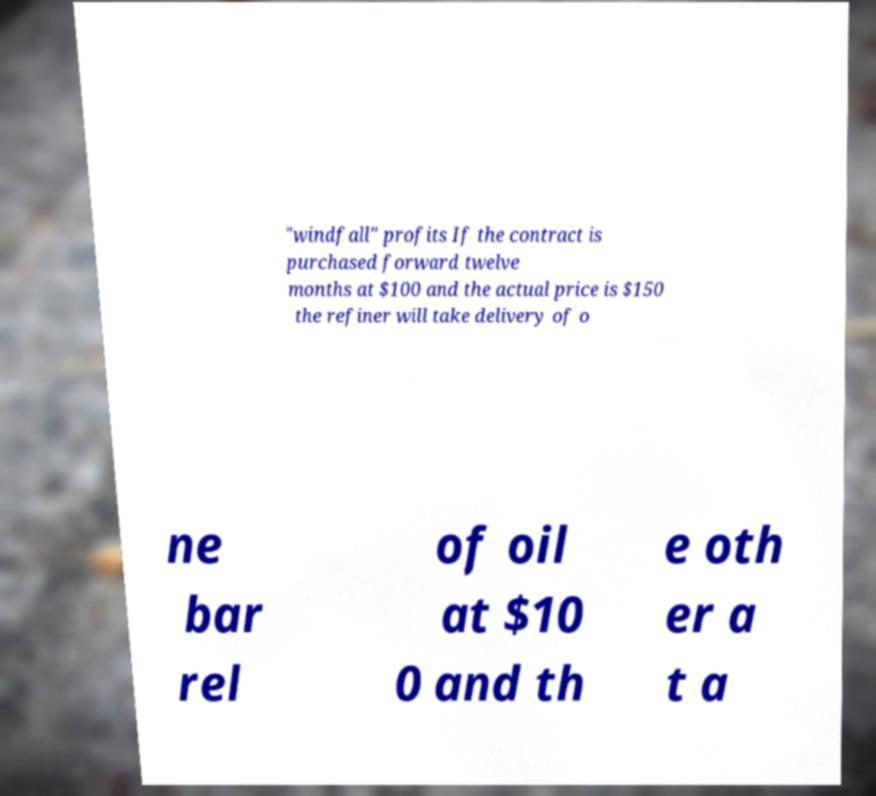Can you accurately transcribe the text from the provided image for me? "windfall" profits If the contract is purchased forward twelve months at $100 and the actual price is $150 the refiner will take delivery of o ne bar rel of oil at $10 0 and th e oth er a t a 